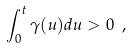<formula> <loc_0><loc_0><loc_500><loc_500>\int _ { 0 } ^ { t } \gamma ( u ) d u > 0 \ ,</formula> 